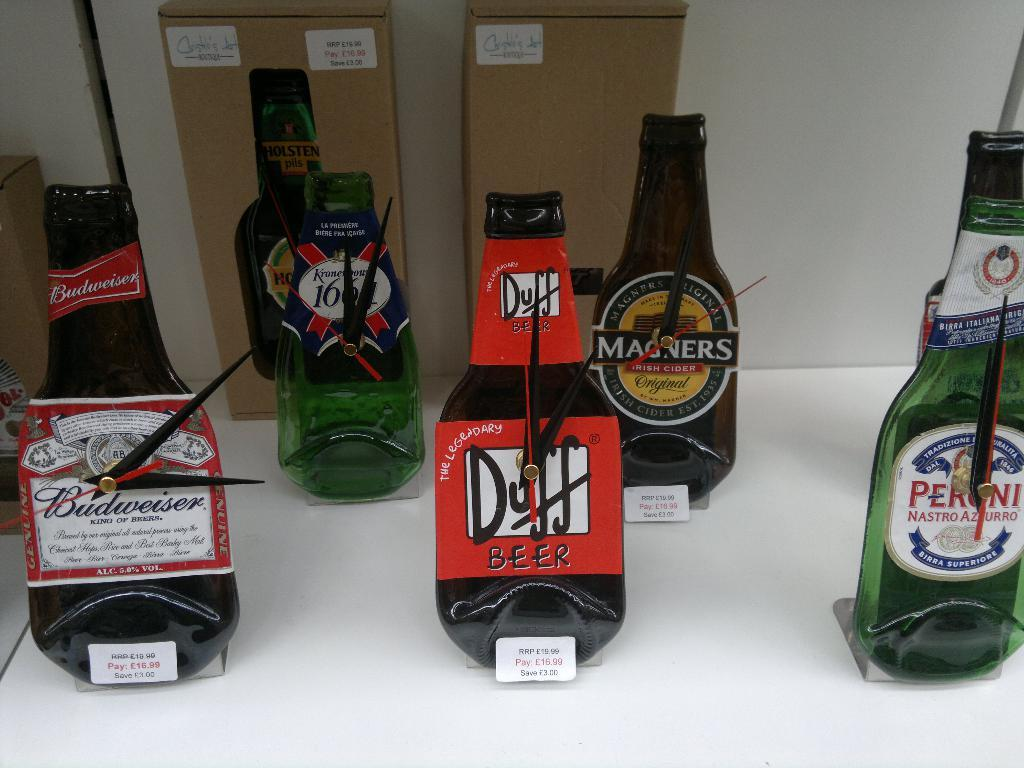What type of items are on the rack in the image? There are alcoholic beverages on a rack in the image. How can you tell the price of the alcoholic beverages? The alcoholic beverages have price tags in the image. What is located behind the rack in the image? There are cardboard boxes behind the rack in the image. How many lines can be seen on the alcoholic beverages? There are no lines visible on the alcoholic beverages in the image. 